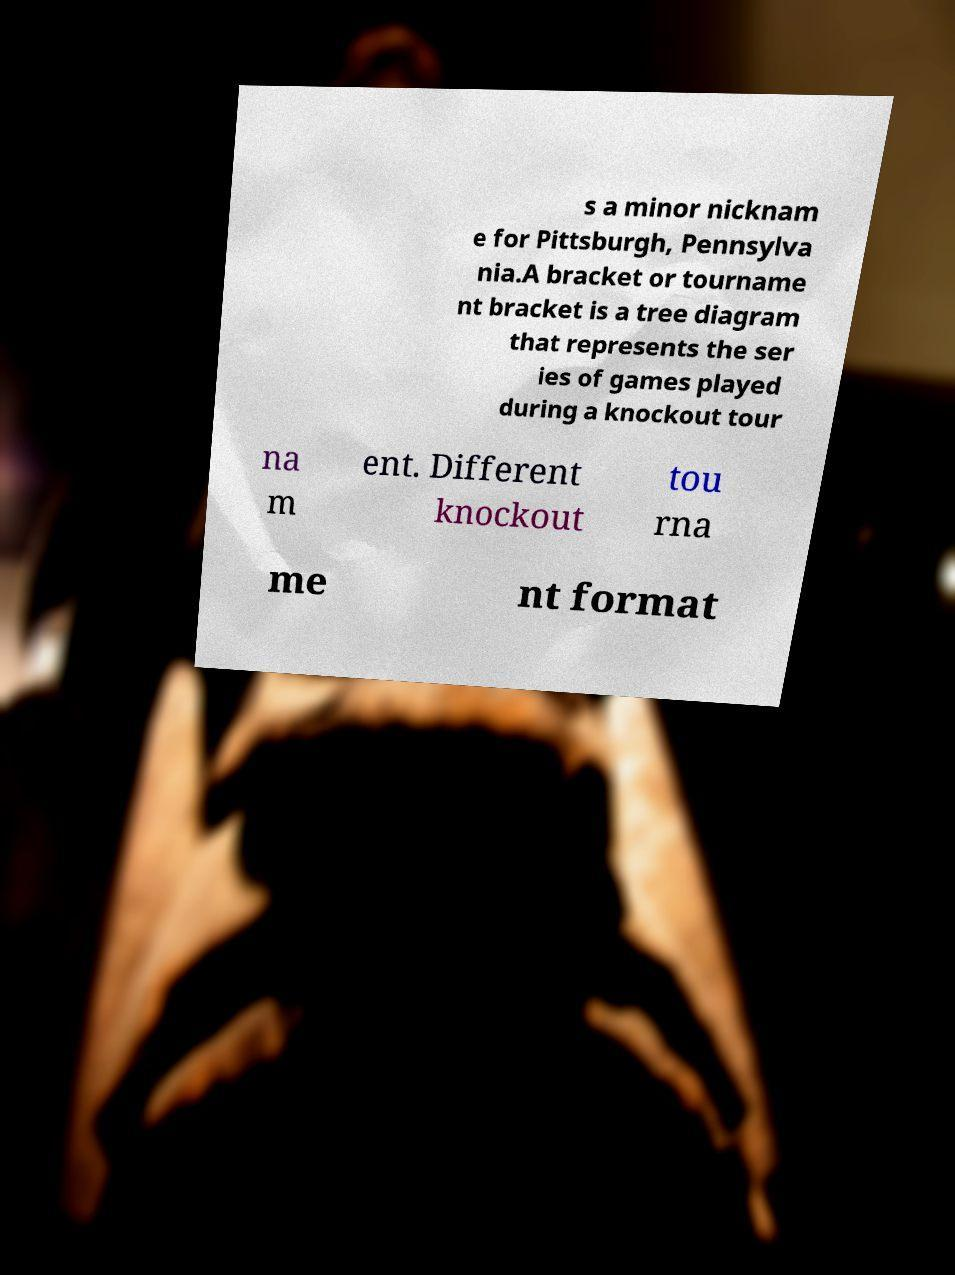Please identify and transcribe the text found in this image. s a minor nicknam e for Pittsburgh, Pennsylva nia.A bracket or tourname nt bracket is a tree diagram that represents the ser ies of games played during a knockout tour na m ent. Different knockout tou rna me nt format 